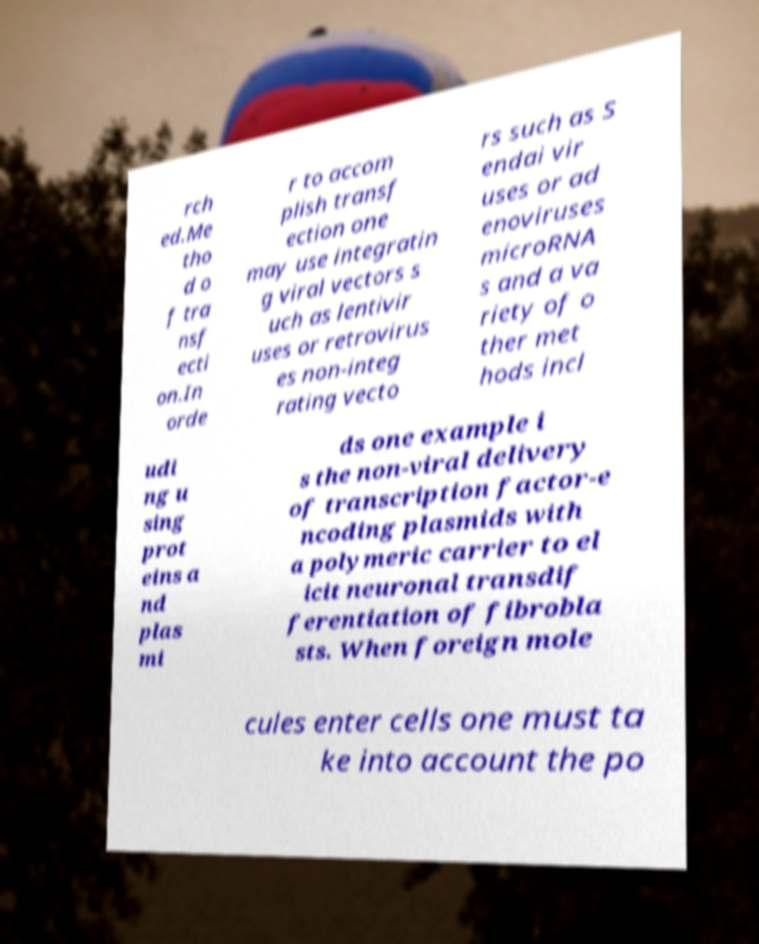There's text embedded in this image that I need extracted. Can you transcribe it verbatim? rch ed.Me tho d o f tra nsf ecti on.In orde r to accom plish transf ection one may use integratin g viral vectors s uch as lentivir uses or retrovirus es non-integ rating vecto rs such as S endai vir uses or ad enoviruses microRNA s and a va riety of o ther met hods incl udi ng u sing prot eins a nd plas mi ds one example i s the non-viral delivery of transcription factor-e ncoding plasmids with a polymeric carrier to el icit neuronal transdif ferentiation of fibrobla sts. When foreign mole cules enter cells one must ta ke into account the po 